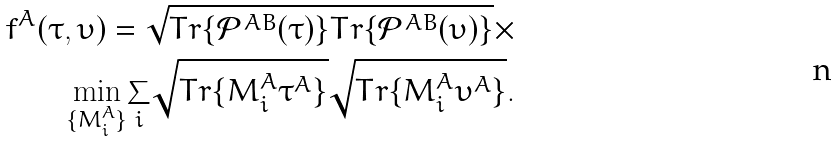<formula> <loc_0><loc_0><loc_500><loc_500>f ^ { A } ( \tau , \upsilon ) = \sqrt { T r \{ \mathcal { P } ^ { A B } ( \tau ) \} T r \{ \mathcal { P } ^ { A B } ( \upsilon ) \} } \times \\ \underset { \{ M ^ { A } _ { i } \} } { \min } \underset { i } { \sum } \sqrt { T r \{ M ^ { A } _ { i } \tau ^ { A } \} } \sqrt { T r \{ M ^ { A } _ { i } \upsilon ^ { A } \} } .</formula> 